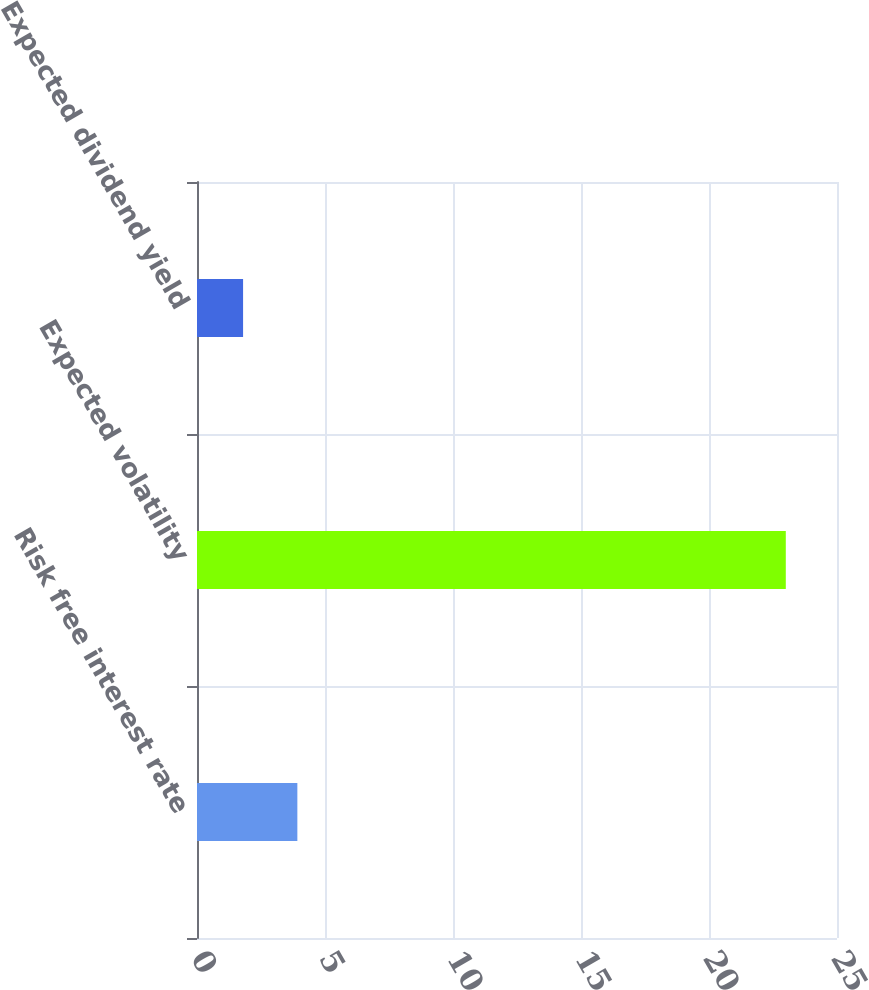Convert chart. <chart><loc_0><loc_0><loc_500><loc_500><bar_chart><fcel>Risk free interest rate<fcel>Expected volatility<fcel>Expected dividend yield<nl><fcel>3.92<fcel>23<fcel>1.8<nl></chart> 